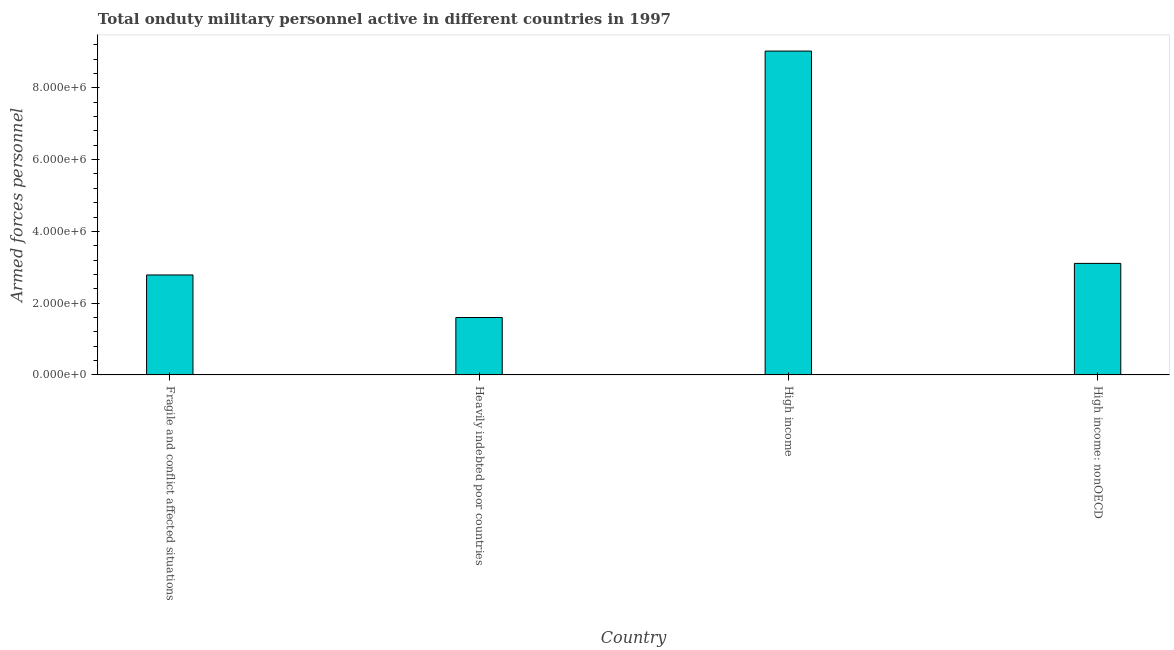What is the title of the graph?
Offer a terse response. Total onduty military personnel active in different countries in 1997. What is the label or title of the X-axis?
Keep it short and to the point. Country. What is the label or title of the Y-axis?
Your response must be concise. Armed forces personnel. What is the number of armed forces personnel in High income?
Your response must be concise. 9.03e+06. Across all countries, what is the maximum number of armed forces personnel?
Provide a short and direct response. 9.03e+06. Across all countries, what is the minimum number of armed forces personnel?
Keep it short and to the point. 1.60e+06. In which country was the number of armed forces personnel maximum?
Offer a very short reply. High income. In which country was the number of armed forces personnel minimum?
Ensure brevity in your answer.  Heavily indebted poor countries. What is the sum of the number of armed forces personnel?
Offer a terse response. 1.65e+07. What is the difference between the number of armed forces personnel in Heavily indebted poor countries and High income?
Your response must be concise. -7.43e+06. What is the average number of armed forces personnel per country?
Provide a succinct answer. 4.13e+06. What is the median number of armed forces personnel?
Give a very brief answer. 2.95e+06. What is the ratio of the number of armed forces personnel in Fragile and conflict affected situations to that in High income: nonOECD?
Give a very brief answer. 0.9. Is the number of armed forces personnel in Fragile and conflict affected situations less than that in High income: nonOECD?
Offer a very short reply. Yes. What is the difference between the highest and the second highest number of armed forces personnel?
Give a very brief answer. 5.92e+06. What is the difference between the highest and the lowest number of armed forces personnel?
Your answer should be compact. 7.43e+06. Are all the bars in the graph horizontal?
Keep it short and to the point. No. How many countries are there in the graph?
Ensure brevity in your answer.  4. What is the Armed forces personnel of Fragile and conflict affected situations?
Keep it short and to the point. 2.79e+06. What is the Armed forces personnel in Heavily indebted poor countries?
Give a very brief answer. 1.60e+06. What is the Armed forces personnel of High income?
Give a very brief answer. 9.03e+06. What is the Armed forces personnel in High income: nonOECD?
Your response must be concise. 3.11e+06. What is the difference between the Armed forces personnel in Fragile and conflict affected situations and Heavily indebted poor countries?
Ensure brevity in your answer.  1.19e+06. What is the difference between the Armed forces personnel in Fragile and conflict affected situations and High income?
Make the answer very short. -6.24e+06. What is the difference between the Armed forces personnel in Fragile and conflict affected situations and High income: nonOECD?
Provide a succinct answer. -3.22e+05. What is the difference between the Armed forces personnel in Heavily indebted poor countries and High income?
Your answer should be compact. -7.43e+06. What is the difference between the Armed forces personnel in Heavily indebted poor countries and High income: nonOECD?
Ensure brevity in your answer.  -1.51e+06. What is the difference between the Armed forces personnel in High income and High income: nonOECD?
Your response must be concise. 5.92e+06. What is the ratio of the Armed forces personnel in Fragile and conflict affected situations to that in Heavily indebted poor countries?
Make the answer very short. 1.74. What is the ratio of the Armed forces personnel in Fragile and conflict affected situations to that in High income?
Your response must be concise. 0.31. What is the ratio of the Armed forces personnel in Fragile and conflict affected situations to that in High income: nonOECD?
Your answer should be very brief. 0.9. What is the ratio of the Armed forces personnel in Heavily indebted poor countries to that in High income?
Ensure brevity in your answer.  0.18. What is the ratio of the Armed forces personnel in Heavily indebted poor countries to that in High income: nonOECD?
Offer a very short reply. 0.52. What is the ratio of the Armed forces personnel in High income to that in High income: nonOECD?
Offer a very short reply. 2.9. 